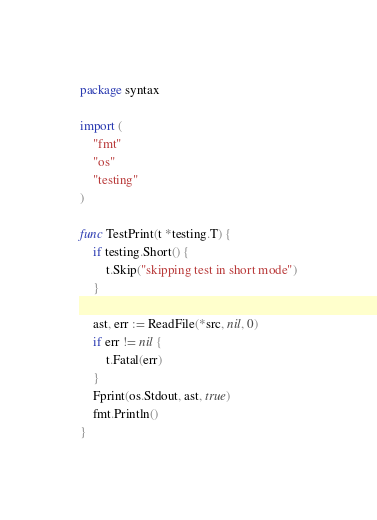Convert code to text. <code><loc_0><loc_0><loc_500><loc_500><_Go_>
package syntax

import (
	"fmt"
	"os"
	"testing"
)

func TestPrint(t *testing.T) {
	if testing.Short() {
		t.Skip("skipping test in short mode")
	}

	ast, err := ReadFile(*src, nil, 0)
	if err != nil {
		t.Fatal(err)
	}
	Fprint(os.Stdout, ast, true)
	fmt.Println()
}
</code> 